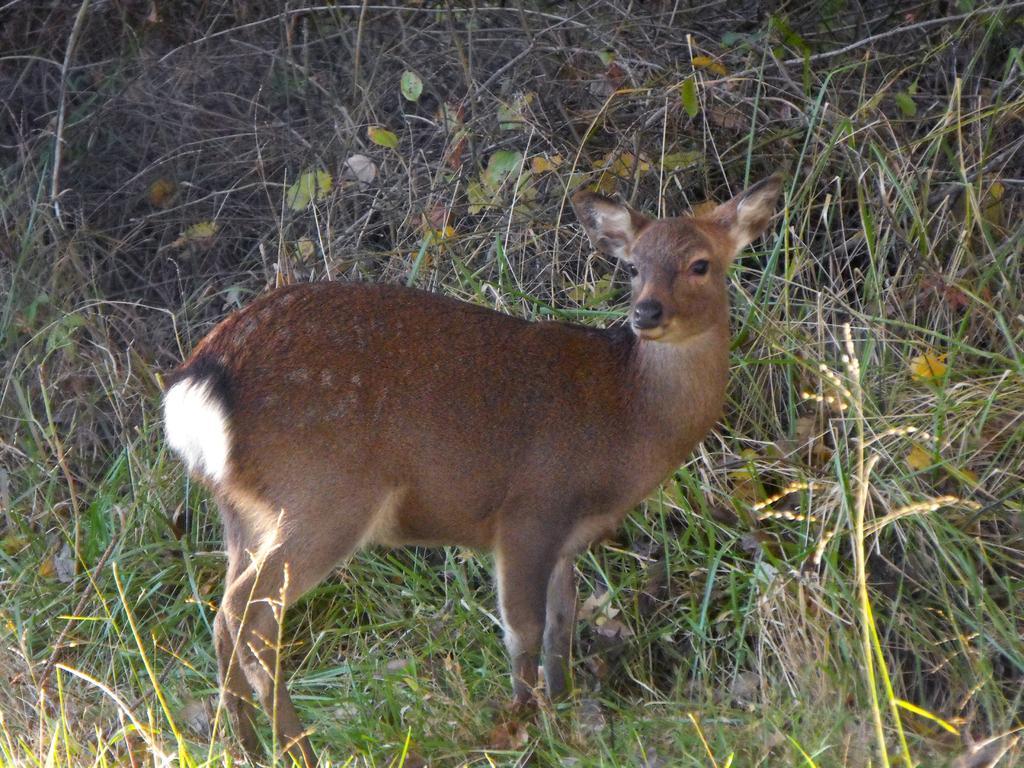How would you summarize this image in a sentence or two? In this picture we can see deer, grass and leaves. 